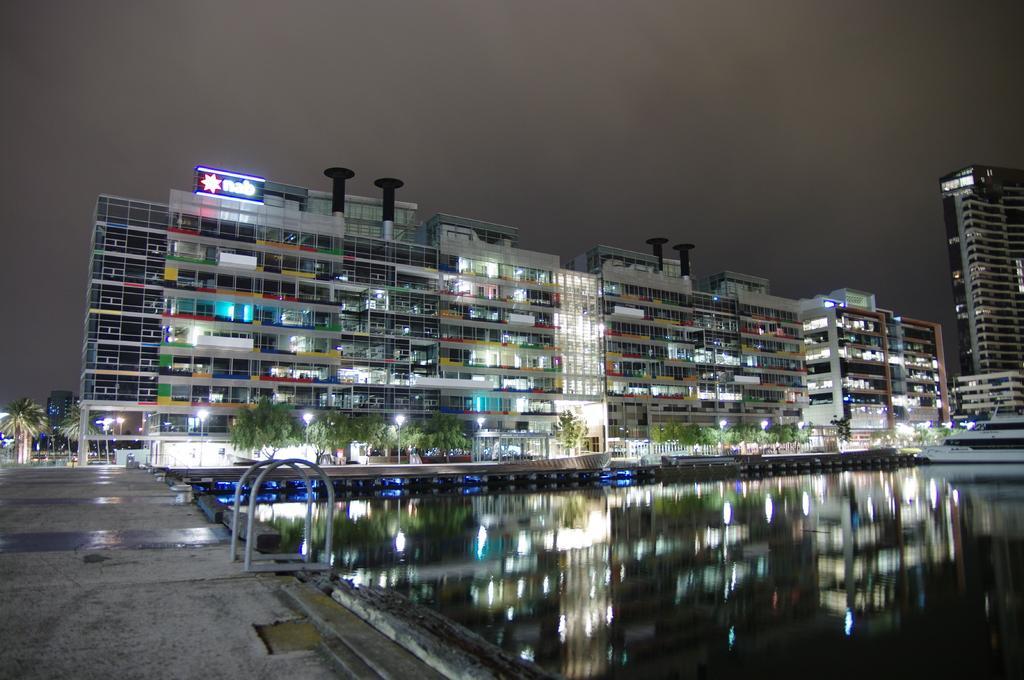Please provide a concise description of this image. In the picture I can see buildings, trees, a boat on the water and street lights. In the background I can see the sky. 